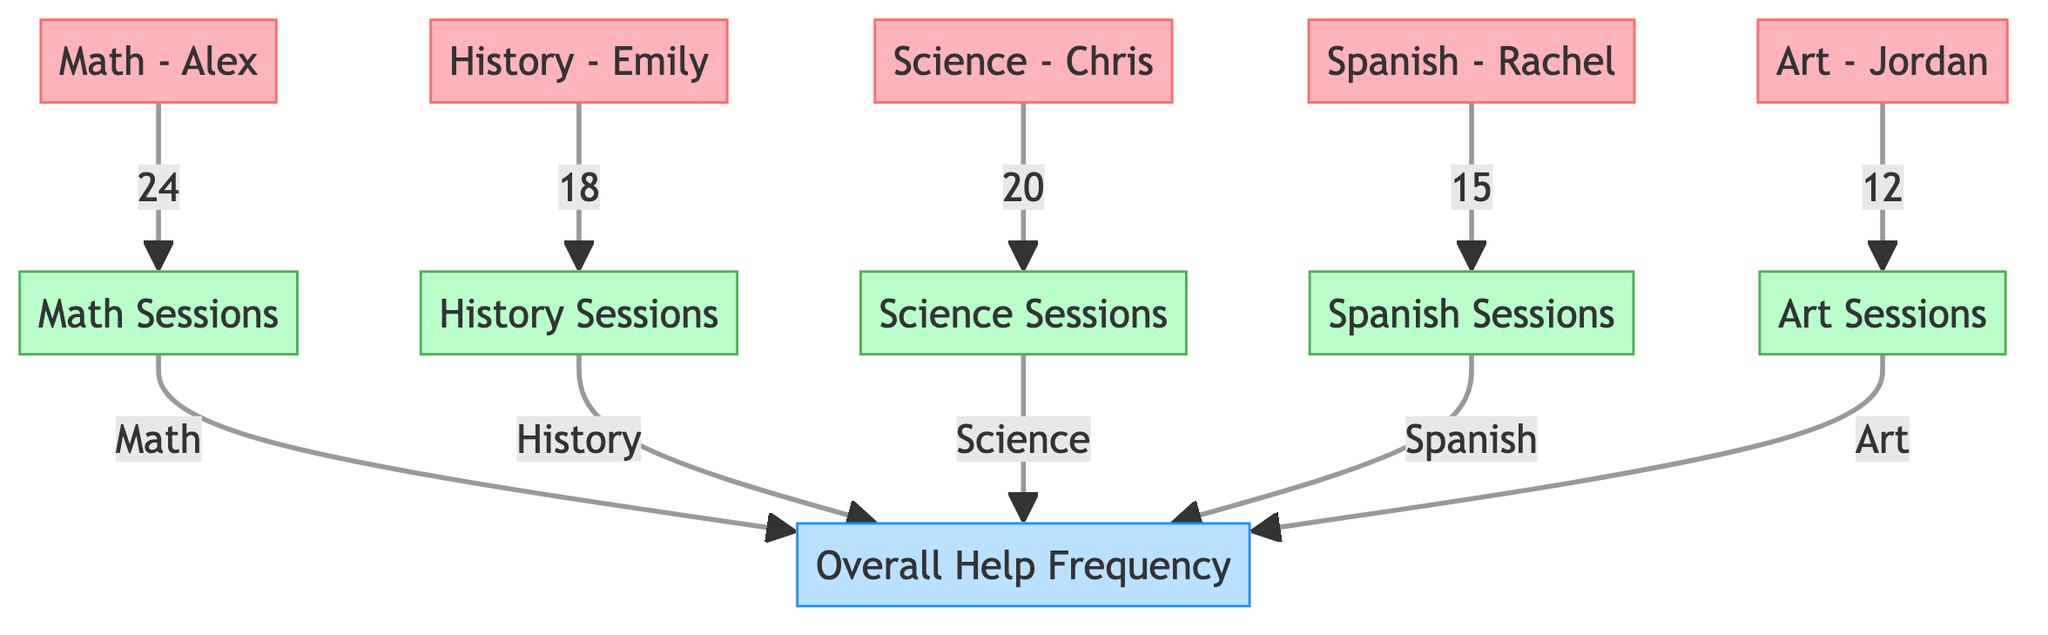What is the highest number of help sessions for a single subject? Looking at the connections from the student nodes to the subject nodes, the largest number indicated is for Math with 24 help sessions.
Answer: 24 Which student received the least help sessions? By examining the students, the one with the lowest number of help sessions is Art - Jordan, who had 12 sessions.
Answer: 12 How many total help sessions were provided across all subjects? To find the total, sum the number of sessions: 24 (Math) + 18 (History) + 20 (Science) + 15 (Spanish) + 12 (Art) equals 89 sessions.
Answer: 89 Which subject had more help sessions: Science or Spanish? A comparison shows that Science had 20 help sessions, while Spanish had 15, making Science the subject with more sessions.
Answer: Science How many students are represented in the diagram? There are five unique student nodes shown in the diagram: Alex, Emily, Chris, Rachel, and Jordan.
Answer: 5 What is the relationship between the subjects and the overall help frequency? Each subject connects to the Overall Help frequency node, collectively contributing to the total frequency of assistance provided during the semester.
Answer: Contributes to overall help Which student had 18 help sessions? The help session node for History corresponds to the student Emily, indicating she had 18 sessions.
Answer: Emily How many subjects are represented in the diagram? The subjects are Math, History, Science, Spanish, and Art, making a total of five distinct subjects represented.
Answer: 5 What is the total number of connections from students to subjects? There are five connections in total, as each student connects to one subject help session node.
Answer: 5 